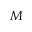<formula> <loc_0><loc_0><loc_500><loc_500>M</formula> 